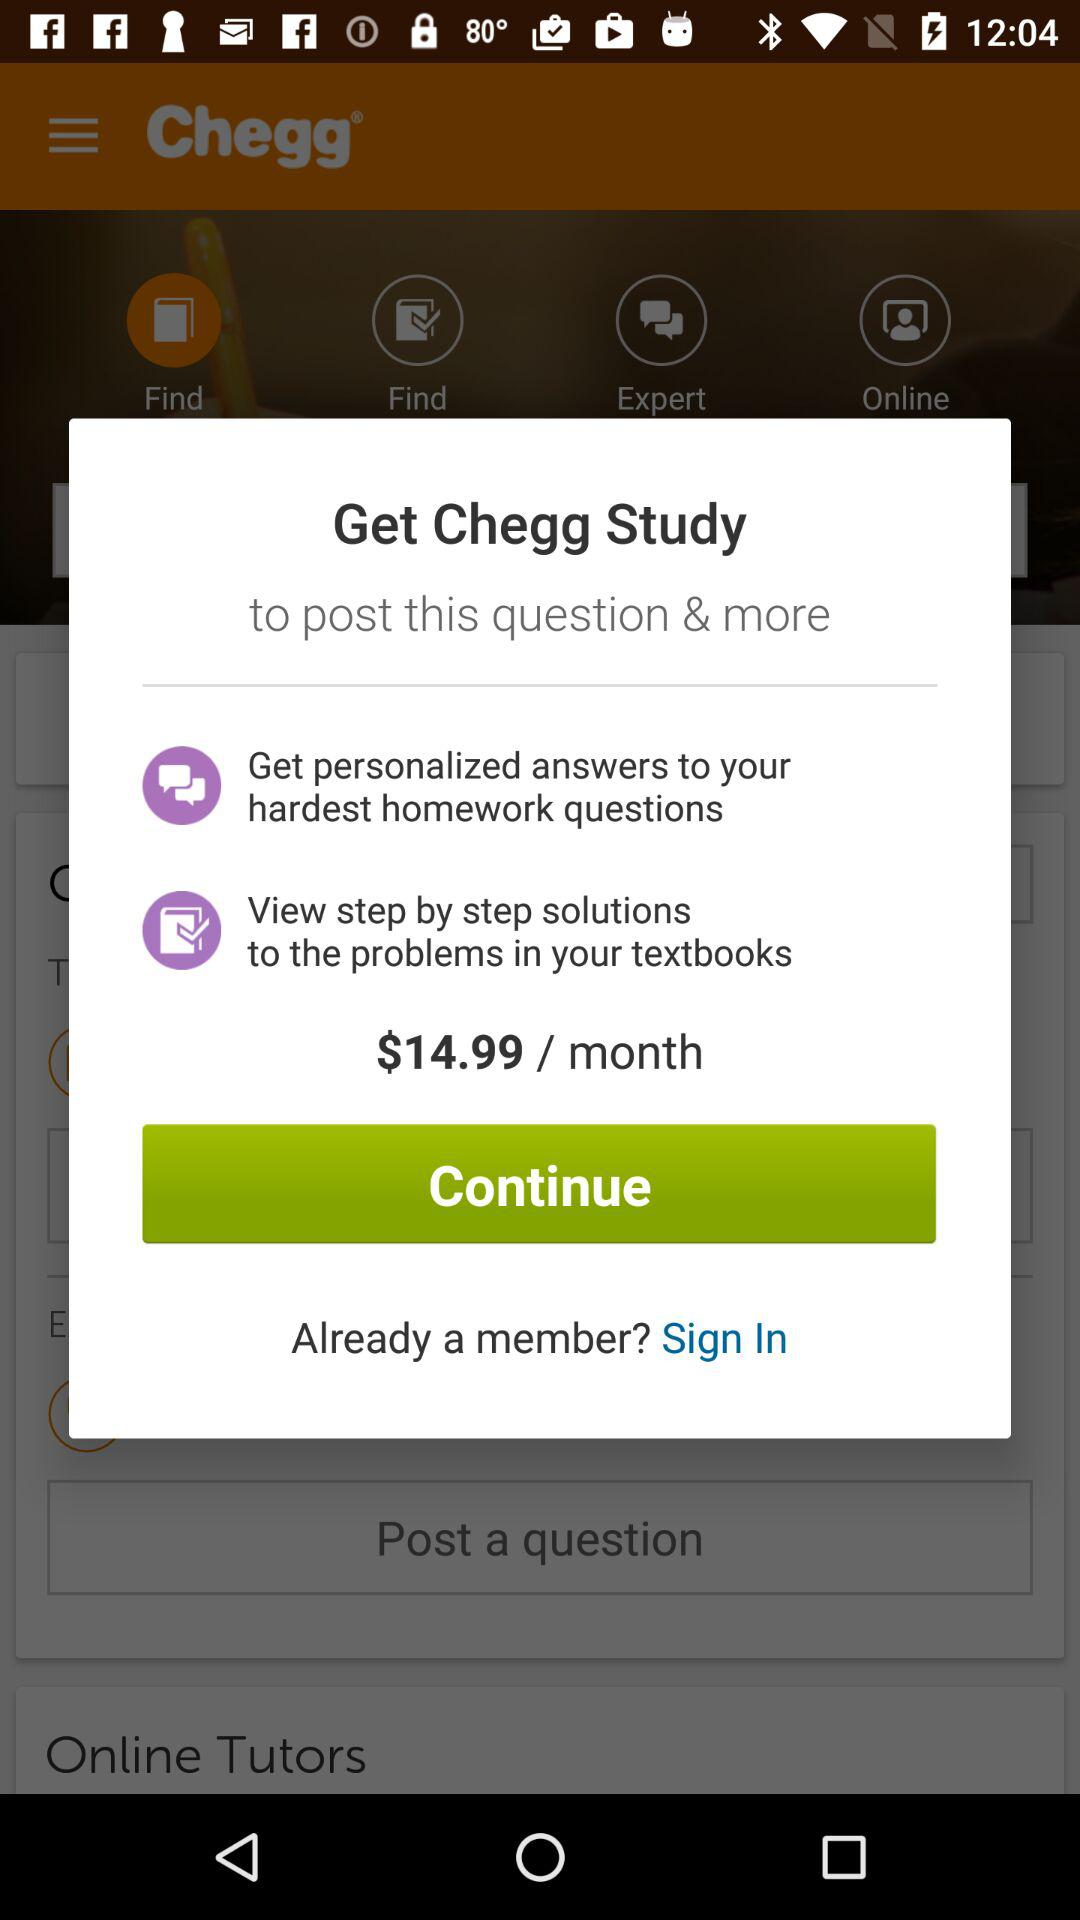What is the per-month charge for the application? The charge for the application is $14.99/month. 